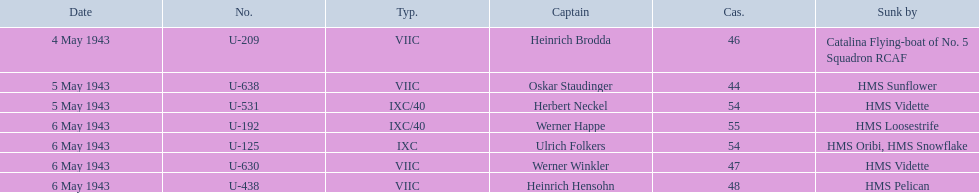What boats were lost on may 5? U-638, U-531. Who were the captains of those boats? Oskar Staudinger, Herbert Neckel. Which captain was not oskar staudinger? Herbert Neckel. 